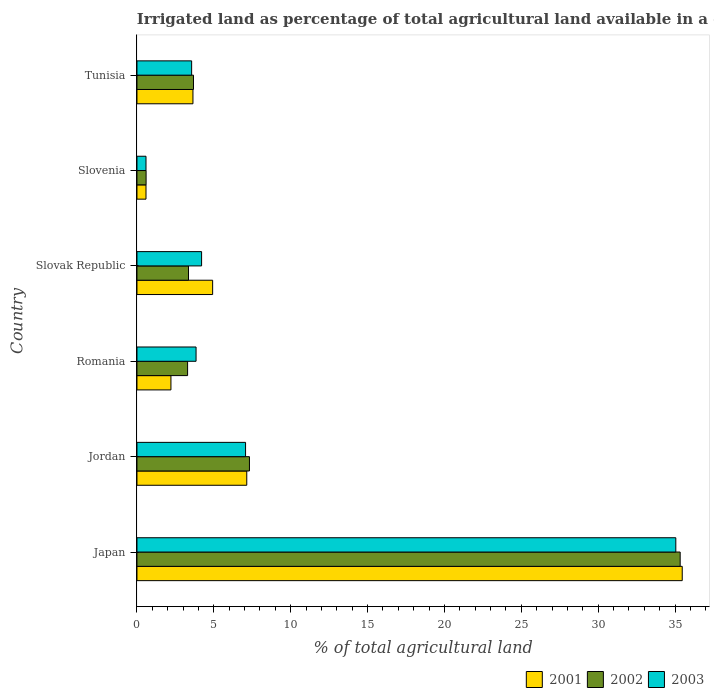How many different coloured bars are there?
Your answer should be very brief. 3. How many bars are there on the 1st tick from the bottom?
Your answer should be compact. 3. What is the label of the 1st group of bars from the top?
Your response must be concise. Tunisia. What is the percentage of irrigated land in 2002 in Jordan?
Your answer should be very brief. 7.32. Across all countries, what is the maximum percentage of irrigated land in 2001?
Provide a short and direct response. 35.47. Across all countries, what is the minimum percentage of irrigated land in 2001?
Your answer should be compact. 0.59. In which country was the percentage of irrigated land in 2003 minimum?
Make the answer very short. Slovenia. What is the total percentage of irrigated land in 2002 in the graph?
Your answer should be very brief. 53.57. What is the difference between the percentage of irrigated land in 2001 in Japan and that in Romania?
Offer a very short reply. 33.26. What is the difference between the percentage of irrigated land in 2003 in Romania and the percentage of irrigated land in 2002 in Japan?
Make the answer very short. -31.49. What is the average percentage of irrigated land in 2003 per country?
Provide a short and direct response. 9.05. What is the difference between the percentage of irrigated land in 2002 and percentage of irrigated land in 2001 in Japan?
Ensure brevity in your answer.  -0.13. In how many countries, is the percentage of irrigated land in 2001 greater than 8 %?
Ensure brevity in your answer.  1. What is the ratio of the percentage of irrigated land in 2001 in Slovak Republic to that in Slovenia?
Your answer should be very brief. 8.37. Is the percentage of irrigated land in 2001 in Jordan less than that in Romania?
Provide a short and direct response. No. Is the difference between the percentage of irrigated land in 2002 in Jordan and Slovenia greater than the difference between the percentage of irrigated land in 2001 in Jordan and Slovenia?
Offer a terse response. Yes. What is the difference between the highest and the second highest percentage of irrigated land in 2002?
Give a very brief answer. 28.02. What is the difference between the highest and the lowest percentage of irrigated land in 2001?
Offer a terse response. 34.88. In how many countries, is the percentage of irrigated land in 2003 greater than the average percentage of irrigated land in 2003 taken over all countries?
Your answer should be very brief. 1. Is the sum of the percentage of irrigated land in 2001 in Jordan and Slovak Republic greater than the maximum percentage of irrigated land in 2003 across all countries?
Keep it short and to the point. No. What is the difference between two consecutive major ticks on the X-axis?
Provide a short and direct response. 5. Does the graph contain any zero values?
Give a very brief answer. No. How many legend labels are there?
Your answer should be very brief. 3. How are the legend labels stacked?
Provide a succinct answer. Horizontal. What is the title of the graph?
Provide a succinct answer. Irrigated land as percentage of total agricultural land available in a country. Does "2012" appear as one of the legend labels in the graph?
Your response must be concise. No. What is the label or title of the X-axis?
Your answer should be compact. % of total agricultural land. What is the label or title of the Y-axis?
Offer a very short reply. Country. What is the % of total agricultural land in 2001 in Japan?
Give a very brief answer. 35.47. What is the % of total agricultural land of 2002 in Japan?
Offer a very short reply. 35.33. What is the % of total agricultural land in 2003 in Japan?
Give a very brief answer. 35.05. What is the % of total agricultural land of 2001 in Jordan?
Offer a terse response. 7.14. What is the % of total agricultural land of 2002 in Jordan?
Offer a very short reply. 7.32. What is the % of total agricultural land of 2003 in Jordan?
Your answer should be very brief. 7.06. What is the % of total agricultural land in 2001 in Romania?
Give a very brief answer. 2.21. What is the % of total agricultural land of 2002 in Romania?
Provide a succinct answer. 3.29. What is the % of total agricultural land in 2003 in Romania?
Provide a succinct answer. 3.84. What is the % of total agricultural land in 2001 in Slovak Republic?
Provide a short and direct response. 4.92. What is the % of total agricultural land of 2002 in Slovak Republic?
Make the answer very short. 3.35. What is the % of total agricultural land of 2003 in Slovak Republic?
Your response must be concise. 4.2. What is the % of total agricultural land of 2001 in Slovenia?
Keep it short and to the point. 0.59. What is the % of total agricultural land in 2002 in Slovenia?
Your response must be concise. 0.59. What is the % of total agricultural land in 2003 in Slovenia?
Provide a short and direct response. 0.59. What is the % of total agricultural land in 2001 in Tunisia?
Provide a short and direct response. 3.64. What is the % of total agricultural land of 2002 in Tunisia?
Offer a very short reply. 3.68. What is the % of total agricultural land of 2003 in Tunisia?
Offer a terse response. 3.56. Across all countries, what is the maximum % of total agricultural land of 2001?
Give a very brief answer. 35.47. Across all countries, what is the maximum % of total agricultural land in 2002?
Your answer should be very brief. 35.33. Across all countries, what is the maximum % of total agricultural land in 2003?
Offer a very short reply. 35.05. Across all countries, what is the minimum % of total agricultural land of 2001?
Your response must be concise. 0.59. Across all countries, what is the minimum % of total agricultural land in 2002?
Ensure brevity in your answer.  0.59. Across all countries, what is the minimum % of total agricultural land of 2003?
Provide a short and direct response. 0.59. What is the total % of total agricultural land in 2001 in the graph?
Ensure brevity in your answer.  53.97. What is the total % of total agricultural land in 2002 in the graph?
Keep it short and to the point. 53.57. What is the total % of total agricultural land in 2003 in the graph?
Ensure brevity in your answer.  54.31. What is the difference between the % of total agricultural land in 2001 in Japan and that in Jordan?
Offer a terse response. 28.33. What is the difference between the % of total agricultural land of 2002 in Japan and that in Jordan?
Keep it short and to the point. 28.02. What is the difference between the % of total agricultural land in 2003 in Japan and that in Jordan?
Ensure brevity in your answer.  27.99. What is the difference between the % of total agricultural land of 2001 in Japan and that in Romania?
Your response must be concise. 33.26. What is the difference between the % of total agricultural land in 2002 in Japan and that in Romania?
Offer a terse response. 32.04. What is the difference between the % of total agricultural land in 2003 in Japan and that in Romania?
Keep it short and to the point. 31.21. What is the difference between the % of total agricultural land in 2001 in Japan and that in Slovak Republic?
Keep it short and to the point. 30.55. What is the difference between the % of total agricultural land in 2002 in Japan and that in Slovak Republic?
Offer a very short reply. 31.98. What is the difference between the % of total agricultural land of 2003 in Japan and that in Slovak Republic?
Provide a short and direct response. 30.85. What is the difference between the % of total agricultural land of 2001 in Japan and that in Slovenia?
Your response must be concise. 34.88. What is the difference between the % of total agricultural land of 2002 in Japan and that in Slovenia?
Ensure brevity in your answer.  34.74. What is the difference between the % of total agricultural land of 2003 in Japan and that in Slovenia?
Provide a succinct answer. 34.46. What is the difference between the % of total agricultural land in 2001 in Japan and that in Tunisia?
Make the answer very short. 31.83. What is the difference between the % of total agricultural land of 2002 in Japan and that in Tunisia?
Keep it short and to the point. 31.66. What is the difference between the % of total agricultural land of 2003 in Japan and that in Tunisia?
Keep it short and to the point. 31.49. What is the difference between the % of total agricultural land in 2001 in Jordan and that in Romania?
Offer a very short reply. 4.93. What is the difference between the % of total agricultural land in 2002 in Jordan and that in Romania?
Ensure brevity in your answer.  4.02. What is the difference between the % of total agricultural land in 2003 in Jordan and that in Romania?
Ensure brevity in your answer.  3.22. What is the difference between the % of total agricultural land in 2001 in Jordan and that in Slovak Republic?
Offer a terse response. 2.22. What is the difference between the % of total agricultural land of 2002 in Jordan and that in Slovak Republic?
Keep it short and to the point. 3.96. What is the difference between the % of total agricultural land in 2003 in Jordan and that in Slovak Republic?
Make the answer very short. 2.86. What is the difference between the % of total agricultural land of 2001 in Jordan and that in Slovenia?
Offer a very short reply. 6.55. What is the difference between the % of total agricultural land of 2002 in Jordan and that in Slovenia?
Keep it short and to the point. 6.72. What is the difference between the % of total agricultural land in 2003 in Jordan and that in Slovenia?
Give a very brief answer. 6.48. What is the difference between the % of total agricultural land in 2001 in Jordan and that in Tunisia?
Your response must be concise. 3.5. What is the difference between the % of total agricultural land in 2002 in Jordan and that in Tunisia?
Make the answer very short. 3.64. What is the difference between the % of total agricultural land of 2003 in Jordan and that in Tunisia?
Your answer should be compact. 3.51. What is the difference between the % of total agricultural land of 2001 in Romania and that in Slovak Republic?
Your answer should be very brief. -2.71. What is the difference between the % of total agricultural land in 2002 in Romania and that in Slovak Republic?
Your response must be concise. -0.06. What is the difference between the % of total agricultural land of 2003 in Romania and that in Slovak Republic?
Give a very brief answer. -0.36. What is the difference between the % of total agricultural land in 2001 in Romania and that in Slovenia?
Offer a terse response. 1.62. What is the difference between the % of total agricultural land of 2002 in Romania and that in Slovenia?
Your response must be concise. 2.7. What is the difference between the % of total agricultural land in 2003 in Romania and that in Slovenia?
Provide a succinct answer. 3.26. What is the difference between the % of total agricultural land of 2001 in Romania and that in Tunisia?
Ensure brevity in your answer.  -1.43. What is the difference between the % of total agricultural land in 2002 in Romania and that in Tunisia?
Provide a succinct answer. -0.38. What is the difference between the % of total agricultural land in 2003 in Romania and that in Tunisia?
Give a very brief answer. 0.29. What is the difference between the % of total agricultural land in 2001 in Slovak Republic and that in Slovenia?
Keep it short and to the point. 4.33. What is the difference between the % of total agricultural land in 2002 in Slovak Republic and that in Slovenia?
Offer a terse response. 2.76. What is the difference between the % of total agricultural land of 2003 in Slovak Republic and that in Slovenia?
Keep it short and to the point. 3.62. What is the difference between the % of total agricultural land in 2001 in Slovak Republic and that in Tunisia?
Ensure brevity in your answer.  1.28. What is the difference between the % of total agricultural land of 2002 in Slovak Republic and that in Tunisia?
Your answer should be compact. -0.32. What is the difference between the % of total agricultural land of 2003 in Slovak Republic and that in Tunisia?
Provide a succinct answer. 0.65. What is the difference between the % of total agricultural land in 2001 in Slovenia and that in Tunisia?
Ensure brevity in your answer.  -3.05. What is the difference between the % of total agricultural land in 2002 in Slovenia and that in Tunisia?
Provide a succinct answer. -3.08. What is the difference between the % of total agricultural land of 2003 in Slovenia and that in Tunisia?
Offer a very short reply. -2.97. What is the difference between the % of total agricultural land of 2001 in Japan and the % of total agricultural land of 2002 in Jordan?
Provide a short and direct response. 28.15. What is the difference between the % of total agricultural land of 2001 in Japan and the % of total agricultural land of 2003 in Jordan?
Make the answer very short. 28.4. What is the difference between the % of total agricultural land in 2002 in Japan and the % of total agricultural land in 2003 in Jordan?
Your answer should be compact. 28.27. What is the difference between the % of total agricultural land in 2001 in Japan and the % of total agricultural land in 2002 in Romania?
Your response must be concise. 32.18. What is the difference between the % of total agricultural land in 2001 in Japan and the % of total agricultural land in 2003 in Romania?
Provide a succinct answer. 31.62. What is the difference between the % of total agricultural land of 2002 in Japan and the % of total agricultural land of 2003 in Romania?
Your answer should be compact. 31.49. What is the difference between the % of total agricultural land of 2001 in Japan and the % of total agricultural land of 2002 in Slovak Republic?
Make the answer very short. 32.12. What is the difference between the % of total agricultural land in 2001 in Japan and the % of total agricultural land in 2003 in Slovak Republic?
Keep it short and to the point. 31.26. What is the difference between the % of total agricultural land in 2002 in Japan and the % of total agricultural land in 2003 in Slovak Republic?
Ensure brevity in your answer.  31.13. What is the difference between the % of total agricultural land of 2001 in Japan and the % of total agricultural land of 2002 in Slovenia?
Provide a short and direct response. 34.87. What is the difference between the % of total agricultural land of 2001 in Japan and the % of total agricultural land of 2003 in Slovenia?
Ensure brevity in your answer.  34.88. What is the difference between the % of total agricultural land of 2002 in Japan and the % of total agricultural land of 2003 in Slovenia?
Offer a terse response. 34.75. What is the difference between the % of total agricultural land in 2001 in Japan and the % of total agricultural land in 2002 in Tunisia?
Your answer should be compact. 31.79. What is the difference between the % of total agricultural land of 2001 in Japan and the % of total agricultural land of 2003 in Tunisia?
Make the answer very short. 31.91. What is the difference between the % of total agricultural land in 2002 in Japan and the % of total agricultural land in 2003 in Tunisia?
Offer a very short reply. 31.78. What is the difference between the % of total agricultural land in 2001 in Jordan and the % of total agricultural land in 2002 in Romania?
Make the answer very short. 3.85. What is the difference between the % of total agricultural land in 2001 in Jordan and the % of total agricultural land in 2003 in Romania?
Ensure brevity in your answer.  3.3. What is the difference between the % of total agricultural land of 2002 in Jordan and the % of total agricultural land of 2003 in Romania?
Ensure brevity in your answer.  3.47. What is the difference between the % of total agricultural land in 2001 in Jordan and the % of total agricultural land in 2002 in Slovak Republic?
Offer a very short reply. 3.79. What is the difference between the % of total agricultural land of 2001 in Jordan and the % of total agricultural land of 2003 in Slovak Republic?
Your answer should be compact. 2.94. What is the difference between the % of total agricultural land in 2002 in Jordan and the % of total agricultural land in 2003 in Slovak Republic?
Make the answer very short. 3.11. What is the difference between the % of total agricultural land of 2001 in Jordan and the % of total agricultural land of 2002 in Slovenia?
Keep it short and to the point. 6.55. What is the difference between the % of total agricultural land in 2001 in Jordan and the % of total agricultural land in 2003 in Slovenia?
Your response must be concise. 6.55. What is the difference between the % of total agricultural land of 2002 in Jordan and the % of total agricultural land of 2003 in Slovenia?
Make the answer very short. 6.73. What is the difference between the % of total agricultural land of 2001 in Jordan and the % of total agricultural land of 2002 in Tunisia?
Offer a very short reply. 3.47. What is the difference between the % of total agricultural land in 2001 in Jordan and the % of total agricultural land in 2003 in Tunisia?
Make the answer very short. 3.59. What is the difference between the % of total agricultural land of 2002 in Jordan and the % of total agricultural land of 2003 in Tunisia?
Provide a short and direct response. 3.76. What is the difference between the % of total agricultural land of 2001 in Romania and the % of total agricultural land of 2002 in Slovak Republic?
Ensure brevity in your answer.  -1.14. What is the difference between the % of total agricultural land of 2001 in Romania and the % of total agricultural land of 2003 in Slovak Republic?
Make the answer very short. -1.99. What is the difference between the % of total agricultural land in 2002 in Romania and the % of total agricultural land in 2003 in Slovak Republic?
Give a very brief answer. -0.91. What is the difference between the % of total agricultural land in 2001 in Romania and the % of total agricultural land in 2002 in Slovenia?
Provide a short and direct response. 1.62. What is the difference between the % of total agricultural land of 2001 in Romania and the % of total agricultural land of 2003 in Slovenia?
Keep it short and to the point. 1.62. What is the difference between the % of total agricultural land of 2002 in Romania and the % of total agricultural land of 2003 in Slovenia?
Your response must be concise. 2.71. What is the difference between the % of total agricultural land in 2001 in Romania and the % of total agricultural land in 2002 in Tunisia?
Ensure brevity in your answer.  -1.47. What is the difference between the % of total agricultural land in 2001 in Romania and the % of total agricultural land in 2003 in Tunisia?
Make the answer very short. -1.35. What is the difference between the % of total agricultural land in 2002 in Romania and the % of total agricultural land in 2003 in Tunisia?
Offer a terse response. -0.26. What is the difference between the % of total agricultural land of 2001 in Slovak Republic and the % of total agricultural land of 2002 in Slovenia?
Offer a very short reply. 4.33. What is the difference between the % of total agricultural land of 2001 in Slovak Republic and the % of total agricultural land of 2003 in Slovenia?
Give a very brief answer. 4.33. What is the difference between the % of total agricultural land of 2002 in Slovak Republic and the % of total agricultural land of 2003 in Slovenia?
Your answer should be compact. 2.76. What is the difference between the % of total agricultural land of 2001 in Slovak Republic and the % of total agricultural land of 2002 in Tunisia?
Provide a short and direct response. 1.25. What is the difference between the % of total agricultural land of 2001 in Slovak Republic and the % of total agricultural land of 2003 in Tunisia?
Offer a terse response. 1.37. What is the difference between the % of total agricultural land of 2002 in Slovak Republic and the % of total agricultural land of 2003 in Tunisia?
Your response must be concise. -0.2. What is the difference between the % of total agricultural land in 2001 in Slovenia and the % of total agricultural land in 2002 in Tunisia?
Keep it short and to the point. -3.09. What is the difference between the % of total agricultural land of 2001 in Slovenia and the % of total agricultural land of 2003 in Tunisia?
Provide a succinct answer. -2.97. What is the difference between the % of total agricultural land of 2002 in Slovenia and the % of total agricultural land of 2003 in Tunisia?
Give a very brief answer. -2.96. What is the average % of total agricultural land of 2001 per country?
Offer a terse response. 9. What is the average % of total agricultural land of 2002 per country?
Ensure brevity in your answer.  8.93. What is the average % of total agricultural land in 2003 per country?
Ensure brevity in your answer.  9.05. What is the difference between the % of total agricultural land in 2001 and % of total agricultural land in 2002 in Japan?
Your answer should be very brief. 0.13. What is the difference between the % of total agricultural land of 2001 and % of total agricultural land of 2003 in Japan?
Offer a terse response. 0.42. What is the difference between the % of total agricultural land of 2002 and % of total agricultural land of 2003 in Japan?
Provide a succinct answer. 0.28. What is the difference between the % of total agricultural land in 2001 and % of total agricultural land in 2002 in Jordan?
Provide a succinct answer. -0.17. What is the difference between the % of total agricultural land of 2001 and % of total agricultural land of 2003 in Jordan?
Keep it short and to the point. 0.08. What is the difference between the % of total agricultural land in 2002 and % of total agricultural land in 2003 in Jordan?
Make the answer very short. 0.25. What is the difference between the % of total agricultural land of 2001 and % of total agricultural land of 2002 in Romania?
Offer a terse response. -1.08. What is the difference between the % of total agricultural land in 2001 and % of total agricultural land in 2003 in Romania?
Your answer should be compact. -1.63. What is the difference between the % of total agricultural land in 2002 and % of total agricultural land in 2003 in Romania?
Give a very brief answer. -0.55. What is the difference between the % of total agricultural land of 2001 and % of total agricultural land of 2002 in Slovak Republic?
Ensure brevity in your answer.  1.57. What is the difference between the % of total agricultural land in 2001 and % of total agricultural land in 2003 in Slovak Republic?
Keep it short and to the point. 0.72. What is the difference between the % of total agricultural land in 2002 and % of total agricultural land in 2003 in Slovak Republic?
Offer a terse response. -0.85. What is the difference between the % of total agricultural land of 2001 and % of total agricultural land of 2002 in Slovenia?
Ensure brevity in your answer.  -0.01. What is the difference between the % of total agricultural land in 2002 and % of total agricultural land in 2003 in Slovenia?
Ensure brevity in your answer.  0.01. What is the difference between the % of total agricultural land of 2001 and % of total agricultural land of 2002 in Tunisia?
Give a very brief answer. -0.03. What is the difference between the % of total agricultural land in 2001 and % of total agricultural land in 2003 in Tunisia?
Your answer should be very brief. 0.09. What is the difference between the % of total agricultural land of 2002 and % of total agricultural land of 2003 in Tunisia?
Provide a succinct answer. 0.12. What is the ratio of the % of total agricultural land of 2001 in Japan to that in Jordan?
Your answer should be very brief. 4.97. What is the ratio of the % of total agricultural land of 2002 in Japan to that in Jordan?
Your answer should be very brief. 4.83. What is the ratio of the % of total agricultural land in 2003 in Japan to that in Jordan?
Keep it short and to the point. 4.96. What is the ratio of the % of total agricultural land of 2001 in Japan to that in Romania?
Give a very brief answer. 16.05. What is the ratio of the % of total agricultural land of 2002 in Japan to that in Romania?
Keep it short and to the point. 10.73. What is the ratio of the % of total agricultural land in 2003 in Japan to that in Romania?
Your response must be concise. 9.12. What is the ratio of the % of total agricultural land of 2001 in Japan to that in Slovak Republic?
Offer a very short reply. 7.21. What is the ratio of the % of total agricultural land of 2002 in Japan to that in Slovak Republic?
Your answer should be very brief. 10.54. What is the ratio of the % of total agricultural land in 2003 in Japan to that in Slovak Republic?
Provide a succinct answer. 8.34. What is the ratio of the % of total agricultural land in 2001 in Japan to that in Slovenia?
Your answer should be compact. 60.3. What is the ratio of the % of total agricultural land of 2002 in Japan to that in Slovenia?
Offer a terse response. 59.48. What is the ratio of the % of total agricultural land of 2003 in Japan to that in Slovenia?
Your answer should be compact. 59.59. What is the ratio of the % of total agricultural land in 2001 in Japan to that in Tunisia?
Ensure brevity in your answer.  9.74. What is the ratio of the % of total agricultural land in 2002 in Japan to that in Tunisia?
Provide a succinct answer. 9.61. What is the ratio of the % of total agricultural land in 2003 in Japan to that in Tunisia?
Offer a terse response. 9.85. What is the ratio of the % of total agricultural land in 2001 in Jordan to that in Romania?
Provide a succinct answer. 3.23. What is the ratio of the % of total agricultural land of 2002 in Jordan to that in Romania?
Offer a terse response. 2.22. What is the ratio of the % of total agricultural land of 2003 in Jordan to that in Romania?
Give a very brief answer. 1.84. What is the ratio of the % of total agricultural land of 2001 in Jordan to that in Slovak Republic?
Keep it short and to the point. 1.45. What is the ratio of the % of total agricultural land in 2002 in Jordan to that in Slovak Republic?
Keep it short and to the point. 2.18. What is the ratio of the % of total agricultural land in 2003 in Jordan to that in Slovak Republic?
Offer a very short reply. 1.68. What is the ratio of the % of total agricultural land in 2001 in Jordan to that in Slovenia?
Provide a short and direct response. 12.14. What is the ratio of the % of total agricultural land of 2002 in Jordan to that in Slovenia?
Offer a terse response. 12.32. What is the ratio of the % of total agricultural land in 2003 in Jordan to that in Slovenia?
Offer a terse response. 12.01. What is the ratio of the % of total agricultural land of 2001 in Jordan to that in Tunisia?
Make the answer very short. 1.96. What is the ratio of the % of total agricultural land of 2002 in Jordan to that in Tunisia?
Provide a succinct answer. 1.99. What is the ratio of the % of total agricultural land of 2003 in Jordan to that in Tunisia?
Provide a succinct answer. 1.99. What is the ratio of the % of total agricultural land of 2001 in Romania to that in Slovak Republic?
Provide a succinct answer. 0.45. What is the ratio of the % of total agricultural land in 2002 in Romania to that in Slovak Republic?
Your response must be concise. 0.98. What is the ratio of the % of total agricultural land in 2003 in Romania to that in Slovak Republic?
Offer a terse response. 0.91. What is the ratio of the % of total agricultural land of 2001 in Romania to that in Slovenia?
Offer a very short reply. 3.76. What is the ratio of the % of total agricultural land in 2002 in Romania to that in Slovenia?
Ensure brevity in your answer.  5.54. What is the ratio of the % of total agricultural land in 2003 in Romania to that in Slovenia?
Give a very brief answer. 6.54. What is the ratio of the % of total agricultural land of 2001 in Romania to that in Tunisia?
Offer a terse response. 0.61. What is the ratio of the % of total agricultural land of 2002 in Romania to that in Tunisia?
Ensure brevity in your answer.  0.9. What is the ratio of the % of total agricultural land in 2003 in Romania to that in Tunisia?
Make the answer very short. 1.08. What is the ratio of the % of total agricultural land in 2001 in Slovak Republic to that in Slovenia?
Offer a terse response. 8.37. What is the ratio of the % of total agricultural land in 2002 in Slovak Republic to that in Slovenia?
Make the answer very short. 5.64. What is the ratio of the % of total agricultural land in 2003 in Slovak Republic to that in Slovenia?
Ensure brevity in your answer.  7.15. What is the ratio of the % of total agricultural land in 2001 in Slovak Republic to that in Tunisia?
Make the answer very short. 1.35. What is the ratio of the % of total agricultural land in 2002 in Slovak Republic to that in Tunisia?
Give a very brief answer. 0.91. What is the ratio of the % of total agricultural land of 2003 in Slovak Republic to that in Tunisia?
Your answer should be compact. 1.18. What is the ratio of the % of total agricultural land of 2001 in Slovenia to that in Tunisia?
Your response must be concise. 0.16. What is the ratio of the % of total agricultural land in 2002 in Slovenia to that in Tunisia?
Make the answer very short. 0.16. What is the ratio of the % of total agricultural land in 2003 in Slovenia to that in Tunisia?
Offer a very short reply. 0.17. What is the difference between the highest and the second highest % of total agricultural land in 2001?
Make the answer very short. 28.33. What is the difference between the highest and the second highest % of total agricultural land of 2002?
Provide a succinct answer. 28.02. What is the difference between the highest and the second highest % of total agricultural land in 2003?
Ensure brevity in your answer.  27.99. What is the difference between the highest and the lowest % of total agricultural land in 2001?
Ensure brevity in your answer.  34.88. What is the difference between the highest and the lowest % of total agricultural land in 2002?
Ensure brevity in your answer.  34.74. What is the difference between the highest and the lowest % of total agricultural land in 2003?
Give a very brief answer. 34.46. 